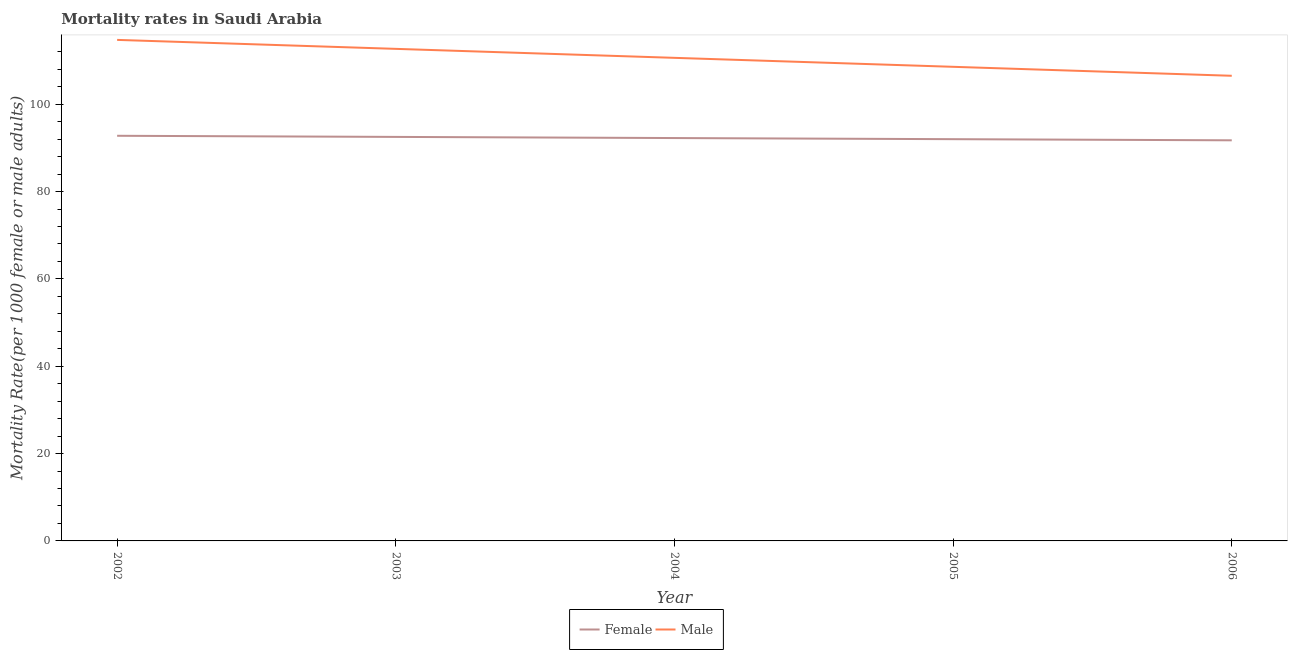Is the number of lines equal to the number of legend labels?
Keep it short and to the point. Yes. What is the male mortality rate in 2006?
Keep it short and to the point. 106.5. Across all years, what is the maximum female mortality rate?
Make the answer very short. 92.77. Across all years, what is the minimum female mortality rate?
Your answer should be very brief. 91.73. What is the total female mortality rate in the graph?
Make the answer very short. 461.23. What is the difference between the female mortality rate in 2004 and that in 2005?
Ensure brevity in your answer.  0.26. What is the difference between the male mortality rate in 2003 and the female mortality rate in 2005?
Provide a succinct answer. 20.68. What is the average male mortality rate per year?
Keep it short and to the point. 110.61. In the year 2006, what is the difference between the female mortality rate and male mortality rate?
Offer a terse response. -14.78. In how many years, is the female mortality rate greater than 44?
Keep it short and to the point. 5. What is the ratio of the female mortality rate in 2003 to that in 2006?
Offer a terse response. 1.01. Is the difference between the male mortality rate in 2003 and 2004 greater than the difference between the female mortality rate in 2003 and 2004?
Your response must be concise. Yes. What is the difference between the highest and the second highest female mortality rate?
Make the answer very short. 0.26. What is the difference between the highest and the lowest male mortality rate?
Make the answer very short. 8.22. In how many years, is the female mortality rate greater than the average female mortality rate taken over all years?
Provide a succinct answer. 3. Is the sum of the male mortality rate in 2003 and 2004 greater than the maximum female mortality rate across all years?
Your response must be concise. Yes. Does the male mortality rate monotonically increase over the years?
Your answer should be very brief. No. How many years are there in the graph?
Offer a terse response. 5. What is the difference between two consecutive major ticks on the Y-axis?
Keep it short and to the point. 20. Does the graph contain any zero values?
Your answer should be very brief. No. Does the graph contain grids?
Provide a succinct answer. No. How many legend labels are there?
Keep it short and to the point. 2. What is the title of the graph?
Keep it short and to the point. Mortality rates in Saudi Arabia. What is the label or title of the Y-axis?
Offer a very short reply. Mortality Rate(per 1000 female or male adults). What is the Mortality Rate(per 1000 female or male adults) in Female in 2002?
Keep it short and to the point. 92.77. What is the Mortality Rate(per 1000 female or male adults) of Male in 2002?
Ensure brevity in your answer.  114.72. What is the Mortality Rate(per 1000 female or male adults) of Female in 2003?
Keep it short and to the point. 92.51. What is the Mortality Rate(per 1000 female or male adults) in Male in 2003?
Your answer should be very brief. 112.67. What is the Mortality Rate(per 1000 female or male adults) in Female in 2004?
Ensure brevity in your answer.  92.25. What is the Mortality Rate(per 1000 female or male adults) of Male in 2004?
Ensure brevity in your answer.  110.61. What is the Mortality Rate(per 1000 female or male adults) of Female in 2005?
Provide a succinct answer. 91.99. What is the Mortality Rate(per 1000 female or male adults) of Male in 2005?
Your response must be concise. 108.56. What is the Mortality Rate(per 1000 female or male adults) of Female in 2006?
Your answer should be very brief. 91.73. What is the Mortality Rate(per 1000 female or male adults) of Male in 2006?
Offer a very short reply. 106.5. Across all years, what is the maximum Mortality Rate(per 1000 female or male adults) in Female?
Provide a short and direct response. 92.77. Across all years, what is the maximum Mortality Rate(per 1000 female or male adults) of Male?
Your response must be concise. 114.72. Across all years, what is the minimum Mortality Rate(per 1000 female or male adults) in Female?
Your response must be concise. 91.73. Across all years, what is the minimum Mortality Rate(per 1000 female or male adults) in Male?
Offer a very short reply. 106.5. What is the total Mortality Rate(per 1000 female or male adults) of Female in the graph?
Your answer should be compact. 461.23. What is the total Mortality Rate(per 1000 female or male adults) of Male in the graph?
Your answer should be very brief. 553.06. What is the difference between the Mortality Rate(per 1000 female or male adults) of Female in 2002 and that in 2003?
Offer a terse response. 0.26. What is the difference between the Mortality Rate(per 1000 female or male adults) of Male in 2002 and that in 2003?
Provide a short and direct response. 2.05. What is the difference between the Mortality Rate(per 1000 female or male adults) of Female in 2002 and that in 2004?
Offer a very short reply. 0.52. What is the difference between the Mortality Rate(per 1000 female or male adults) in Male in 2002 and that in 2004?
Offer a terse response. 4.11. What is the difference between the Mortality Rate(per 1000 female or male adults) in Female in 2002 and that in 2005?
Keep it short and to the point. 0.78. What is the difference between the Mortality Rate(per 1000 female or male adults) of Male in 2002 and that in 2005?
Offer a terse response. 6.16. What is the difference between the Mortality Rate(per 1000 female or male adults) of Female in 2002 and that in 2006?
Offer a terse response. 1.04. What is the difference between the Mortality Rate(per 1000 female or male adults) of Male in 2002 and that in 2006?
Provide a short and direct response. 8.22. What is the difference between the Mortality Rate(per 1000 female or male adults) in Female in 2003 and that in 2004?
Your response must be concise. 0.26. What is the difference between the Mortality Rate(per 1000 female or male adults) of Male in 2003 and that in 2004?
Provide a succinct answer. 2.05. What is the difference between the Mortality Rate(per 1000 female or male adults) in Female in 2003 and that in 2005?
Keep it short and to the point. 0.52. What is the difference between the Mortality Rate(per 1000 female or male adults) in Male in 2003 and that in 2005?
Ensure brevity in your answer.  4.11. What is the difference between the Mortality Rate(per 1000 female or male adults) of Female in 2003 and that in 2006?
Your answer should be compact. 0.78. What is the difference between the Mortality Rate(per 1000 female or male adults) of Male in 2003 and that in 2006?
Ensure brevity in your answer.  6.16. What is the difference between the Mortality Rate(per 1000 female or male adults) in Female in 2004 and that in 2005?
Offer a very short reply. 0.26. What is the difference between the Mortality Rate(per 1000 female or male adults) of Male in 2004 and that in 2005?
Give a very brief answer. 2.06. What is the difference between the Mortality Rate(per 1000 female or male adults) of Female in 2004 and that in 2006?
Give a very brief answer. 0.52. What is the difference between the Mortality Rate(per 1000 female or male adults) in Male in 2004 and that in 2006?
Provide a succinct answer. 4.11. What is the difference between the Mortality Rate(per 1000 female or male adults) in Female in 2005 and that in 2006?
Offer a terse response. 0.26. What is the difference between the Mortality Rate(per 1000 female or male adults) in Male in 2005 and that in 2006?
Provide a short and direct response. 2.05. What is the difference between the Mortality Rate(per 1000 female or male adults) in Female in 2002 and the Mortality Rate(per 1000 female or male adults) in Male in 2003?
Ensure brevity in your answer.  -19.9. What is the difference between the Mortality Rate(per 1000 female or male adults) of Female in 2002 and the Mortality Rate(per 1000 female or male adults) of Male in 2004?
Give a very brief answer. -17.85. What is the difference between the Mortality Rate(per 1000 female or male adults) of Female in 2002 and the Mortality Rate(per 1000 female or male adults) of Male in 2005?
Give a very brief answer. -15.79. What is the difference between the Mortality Rate(per 1000 female or male adults) in Female in 2002 and the Mortality Rate(per 1000 female or male adults) in Male in 2006?
Your answer should be compact. -13.74. What is the difference between the Mortality Rate(per 1000 female or male adults) of Female in 2003 and the Mortality Rate(per 1000 female or male adults) of Male in 2004?
Provide a short and direct response. -18.11. What is the difference between the Mortality Rate(per 1000 female or male adults) of Female in 2003 and the Mortality Rate(per 1000 female or male adults) of Male in 2005?
Ensure brevity in your answer.  -16.05. What is the difference between the Mortality Rate(per 1000 female or male adults) in Female in 2003 and the Mortality Rate(per 1000 female or male adults) in Male in 2006?
Offer a terse response. -14. What is the difference between the Mortality Rate(per 1000 female or male adults) of Female in 2004 and the Mortality Rate(per 1000 female or male adults) of Male in 2005?
Offer a terse response. -16.31. What is the difference between the Mortality Rate(per 1000 female or male adults) of Female in 2004 and the Mortality Rate(per 1000 female or male adults) of Male in 2006?
Offer a terse response. -14.26. What is the difference between the Mortality Rate(per 1000 female or male adults) of Female in 2005 and the Mortality Rate(per 1000 female or male adults) of Male in 2006?
Offer a terse response. -14.52. What is the average Mortality Rate(per 1000 female or male adults) of Female per year?
Offer a very short reply. 92.25. What is the average Mortality Rate(per 1000 female or male adults) of Male per year?
Your response must be concise. 110.61. In the year 2002, what is the difference between the Mortality Rate(per 1000 female or male adults) of Female and Mortality Rate(per 1000 female or male adults) of Male?
Offer a terse response. -21.95. In the year 2003, what is the difference between the Mortality Rate(per 1000 female or male adults) in Female and Mortality Rate(per 1000 female or male adults) in Male?
Make the answer very short. -20.16. In the year 2004, what is the difference between the Mortality Rate(per 1000 female or male adults) in Female and Mortality Rate(per 1000 female or male adults) in Male?
Provide a succinct answer. -18.36. In the year 2005, what is the difference between the Mortality Rate(per 1000 female or male adults) of Female and Mortality Rate(per 1000 female or male adults) of Male?
Offer a very short reply. -16.57. In the year 2006, what is the difference between the Mortality Rate(per 1000 female or male adults) of Female and Mortality Rate(per 1000 female or male adults) of Male?
Provide a short and direct response. -14.78. What is the ratio of the Mortality Rate(per 1000 female or male adults) in Female in 2002 to that in 2003?
Offer a very short reply. 1. What is the ratio of the Mortality Rate(per 1000 female or male adults) in Male in 2002 to that in 2003?
Provide a short and direct response. 1.02. What is the ratio of the Mortality Rate(per 1000 female or male adults) of Female in 2002 to that in 2004?
Your answer should be compact. 1.01. What is the ratio of the Mortality Rate(per 1000 female or male adults) in Male in 2002 to that in 2004?
Offer a terse response. 1.04. What is the ratio of the Mortality Rate(per 1000 female or male adults) of Female in 2002 to that in 2005?
Your response must be concise. 1.01. What is the ratio of the Mortality Rate(per 1000 female or male adults) of Male in 2002 to that in 2005?
Ensure brevity in your answer.  1.06. What is the ratio of the Mortality Rate(per 1000 female or male adults) of Female in 2002 to that in 2006?
Give a very brief answer. 1.01. What is the ratio of the Mortality Rate(per 1000 female or male adults) of Male in 2002 to that in 2006?
Provide a short and direct response. 1.08. What is the ratio of the Mortality Rate(per 1000 female or male adults) in Male in 2003 to that in 2004?
Offer a very short reply. 1.02. What is the ratio of the Mortality Rate(per 1000 female or male adults) of Female in 2003 to that in 2005?
Your answer should be compact. 1.01. What is the ratio of the Mortality Rate(per 1000 female or male adults) in Male in 2003 to that in 2005?
Give a very brief answer. 1.04. What is the ratio of the Mortality Rate(per 1000 female or male adults) in Female in 2003 to that in 2006?
Provide a short and direct response. 1.01. What is the ratio of the Mortality Rate(per 1000 female or male adults) of Male in 2003 to that in 2006?
Your answer should be compact. 1.06. What is the ratio of the Mortality Rate(per 1000 female or male adults) in Male in 2004 to that in 2005?
Your answer should be very brief. 1.02. What is the ratio of the Mortality Rate(per 1000 female or male adults) of Male in 2004 to that in 2006?
Provide a succinct answer. 1.04. What is the ratio of the Mortality Rate(per 1000 female or male adults) of Male in 2005 to that in 2006?
Your response must be concise. 1.02. What is the difference between the highest and the second highest Mortality Rate(per 1000 female or male adults) in Female?
Offer a terse response. 0.26. What is the difference between the highest and the second highest Mortality Rate(per 1000 female or male adults) of Male?
Offer a very short reply. 2.05. What is the difference between the highest and the lowest Mortality Rate(per 1000 female or male adults) in Male?
Offer a terse response. 8.22. 